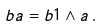<formula> <loc_0><loc_0><loc_500><loc_500>b a & = b 1 \wedge a \, .</formula> 